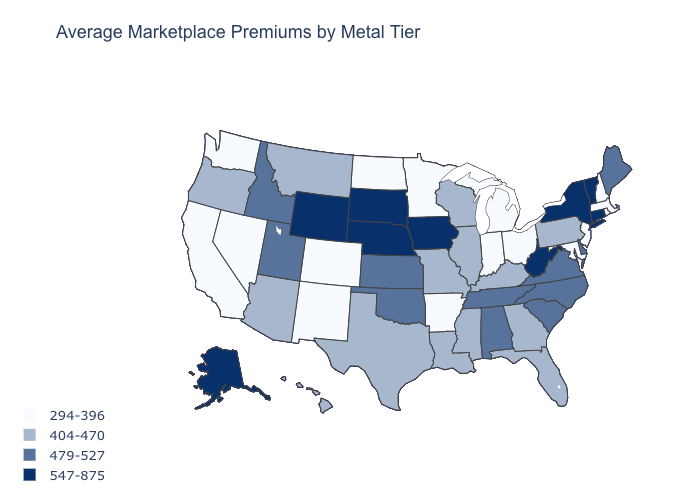What is the value of Iowa?
Be succinct. 547-875. Is the legend a continuous bar?
Quick response, please. No. What is the lowest value in the USA?
Concise answer only. 294-396. What is the lowest value in the West?
Concise answer only. 294-396. Among the states that border New Hampshire , which have the highest value?
Answer briefly. Vermont. Which states have the highest value in the USA?
Concise answer only. Alaska, Connecticut, Iowa, Nebraska, New York, South Dakota, Vermont, West Virginia, Wyoming. What is the lowest value in the West?
Answer briefly. 294-396. Does California have the highest value in the West?
Give a very brief answer. No. Name the states that have a value in the range 294-396?
Be succinct. Arkansas, California, Colorado, Indiana, Maryland, Massachusetts, Michigan, Minnesota, Nevada, New Hampshire, New Jersey, New Mexico, North Dakota, Ohio, Rhode Island, Washington. Among the states that border Missouri , does Arkansas have the lowest value?
Quick response, please. Yes. What is the value of Rhode Island?
Keep it brief. 294-396. Does Louisiana have a lower value than New Mexico?
Keep it brief. No. What is the value of Maryland?
Keep it brief. 294-396. Among the states that border Michigan , does Wisconsin have the lowest value?
Be succinct. No. Which states have the lowest value in the USA?
Write a very short answer. Arkansas, California, Colorado, Indiana, Maryland, Massachusetts, Michigan, Minnesota, Nevada, New Hampshire, New Jersey, New Mexico, North Dakota, Ohio, Rhode Island, Washington. 